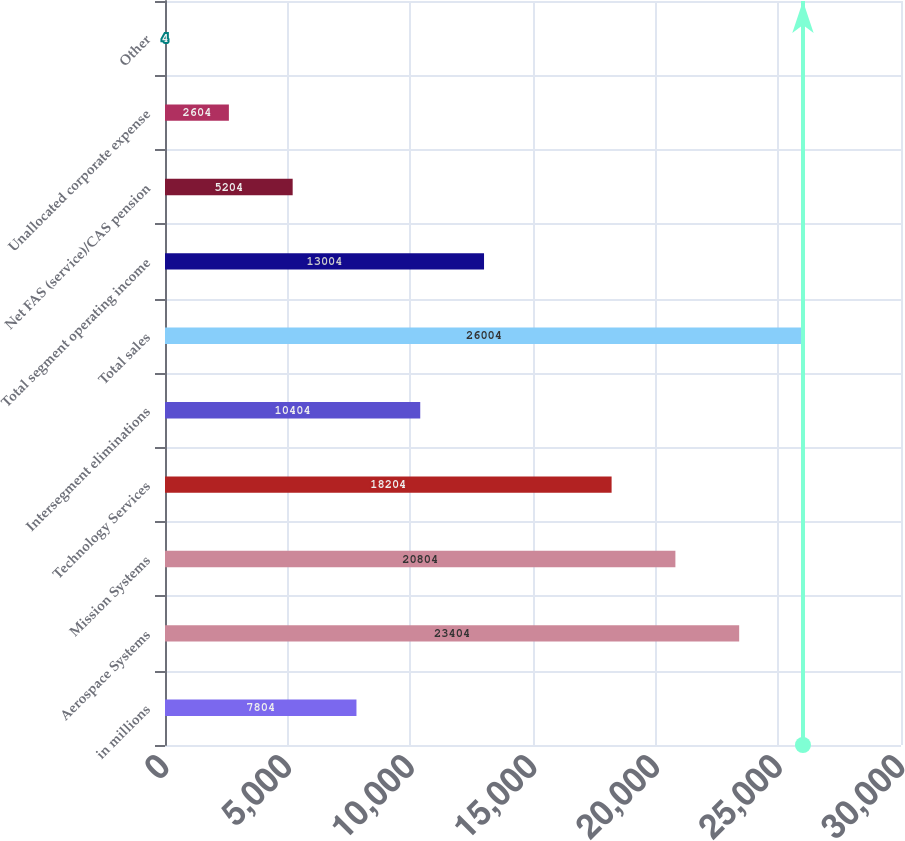Convert chart. <chart><loc_0><loc_0><loc_500><loc_500><bar_chart><fcel>in millions<fcel>Aerospace Systems<fcel>Mission Systems<fcel>Technology Services<fcel>Intersegment eliminations<fcel>Total sales<fcel>Total segment operating income<fcel>Net FAS (service)/CAS pension<fcel>Unallocated corporate expense<fcel>Other<nl><fcel>7804<fcel>23404<fcel>20804<fcel>18204<fcel>10404<fcel>26004<fcel>13004<fcel>5204<fcel>2604<fcel>4<nl></chart> 